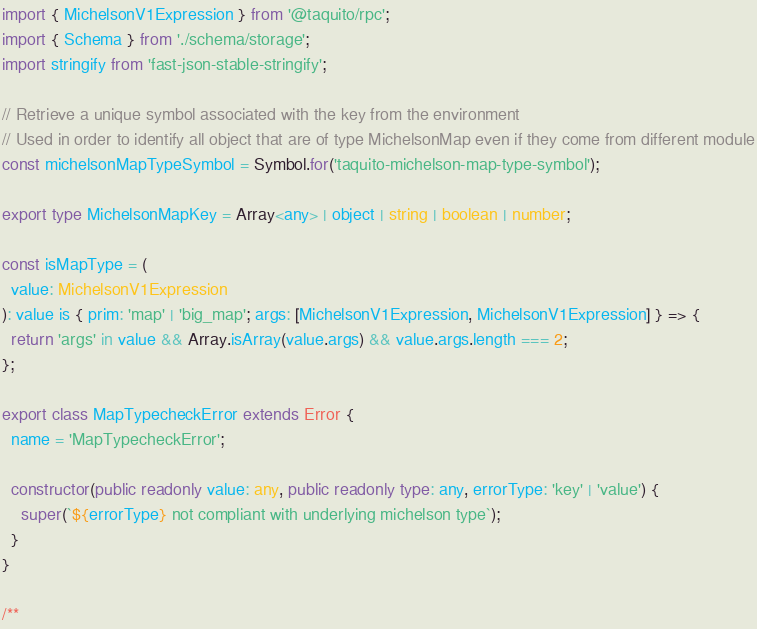<code> <loc_0><loc_0><loc_500><loc_500><_TypeScript_>import { MichelsonV1Expression } from '@taquito/rpc';
import { Schema } from './schema/storage';
import stringify from 'fast-json-stable-stringify';

// Retrieve a unique symbol associated with the key from the environment
// Used in order to identify all object that are of type MichelsonMap even if they come from different module
const michelsonMapTypeSymbol = Symbol.for('taquito-michelson-map-type-symbol');

export type MichelsonMapKey = Array<any> | object | string | boolean | number;

const isMapType = (
  value: MichelsonV1Expression
): value is { prim: 'map' | 'big_map'; args: [MichelsonV1Expression, MichelsonV1Expression] } => {
  return 'args' in value && Array.isArray(value.args) && value.args.length === 2;
};

export class MapTypecheckError extends Error {
  name = 'MapTypecheckError';

  constructor(public readonly value: any, public readonly type: any, errorType: 'key' | 'value') {
    super(`${errorType} not compliant with underlying michelson type`);
  }
}

/**</code> 